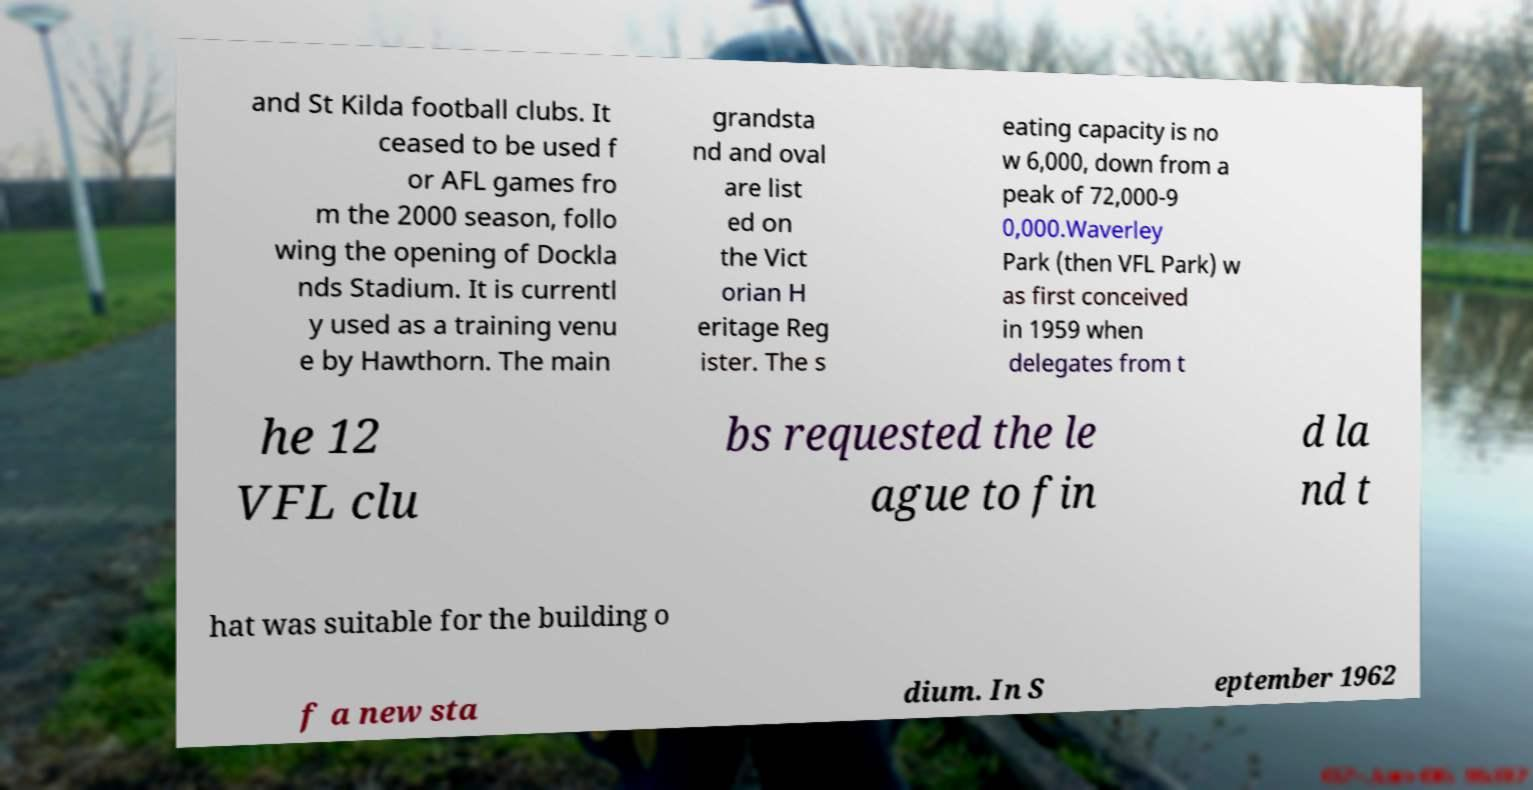For documentation purposes, I need the text within this image transcribed. Could you provide that? and St Kilda football clubs. It ceased to be used f or AFL games fro m the 2000 season, follo wing the opening of Dockla nds Stadium. It is currentl y used as a training venu e by Hawthorn. The main grandsta nd and oval are list ed on the Vict orian H eritage Reg ister. The s eating capacity is no w 6,000, down from a peak of 72,000-9 0,000.Waverley Park (then VFL Park) w as first conceived in 1959 when delegates from t he 12 VFL clu bs requested the le ague to fin d la nd t hat was suitable for the building o f a new sta dium. In S eptember 1962 